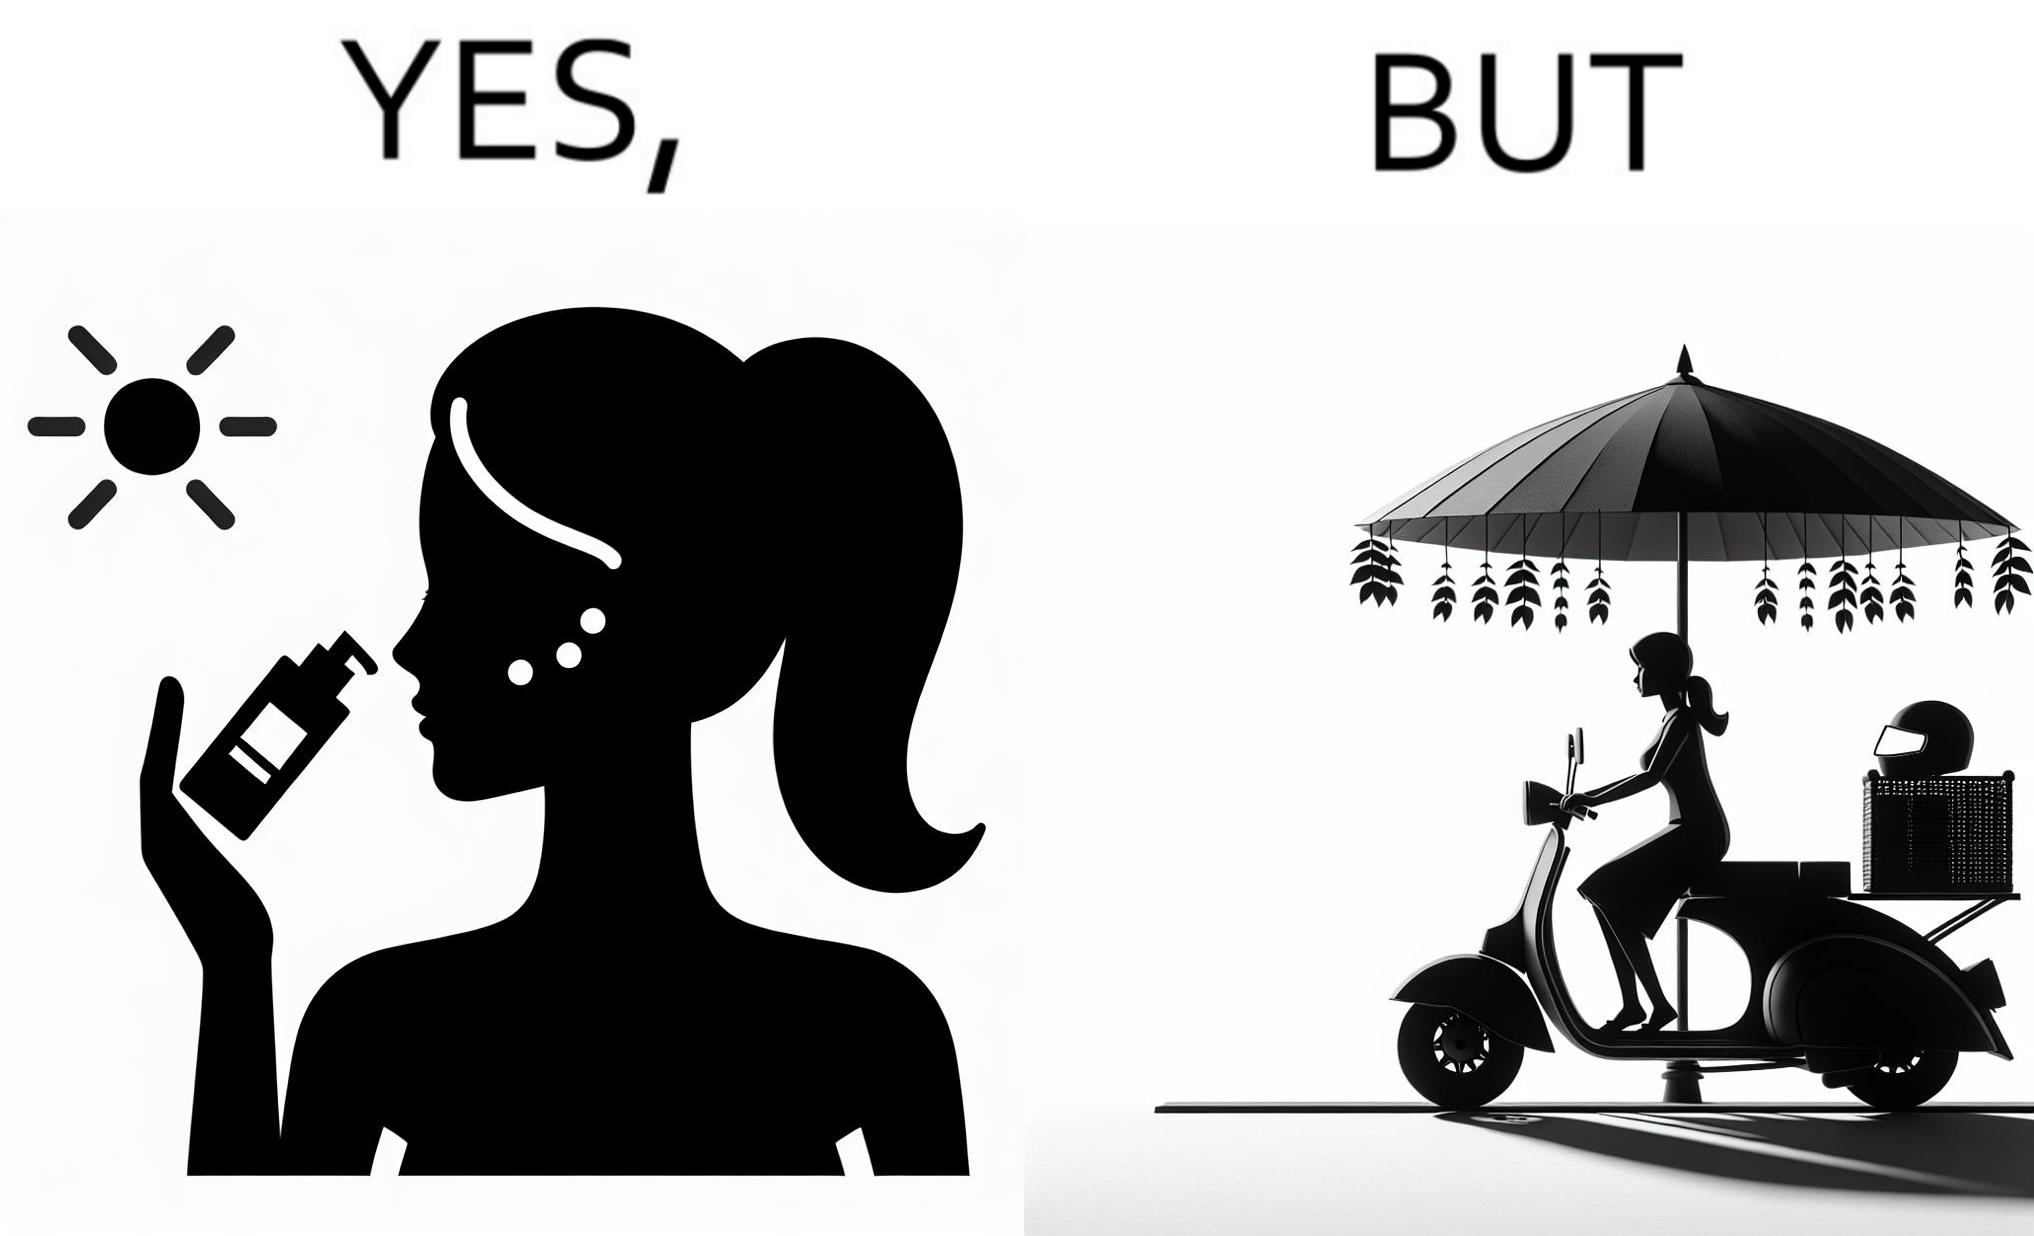What makes this image funny or satirical? The image is funny because while the woman is concerned about protection from the sun rays, she is not concerned about her safety while riding a scooter. 